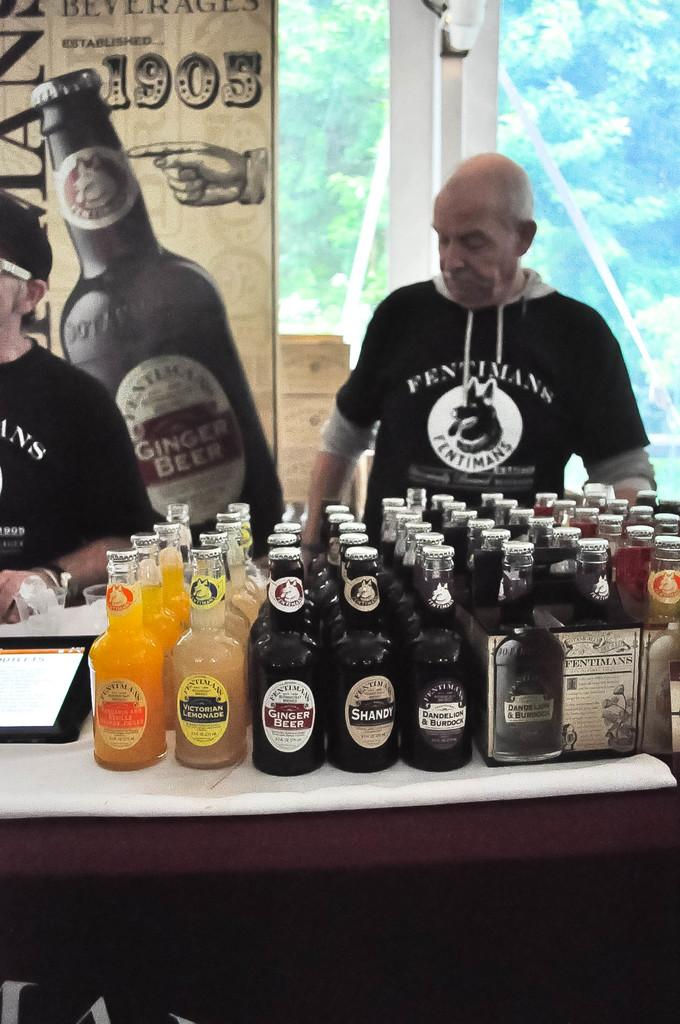<image>
Give a short and clear explanation of the subsequent image. A table arranged with beverages includes flavors such as Victorian Lemonade, Ginger Beer and Shandy. 